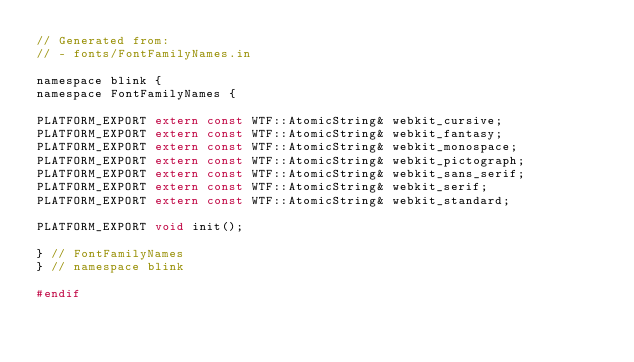Convert code to text. <code><loc_0><loc_0><loc_500><loc_500><_C_>// Generated from:
// - fonts/FontFamilyNames.in

namespace blink {
namespace FontFamilyNames {

PLATFORM_EXPORT extern const WTF::AtomicString& webkit_cursive;
PLATFORM_EXPORT extern const WTF::AtomicString& webkit_fantasy;
PLATFORM_EXPORT extern const WTF::AtomicString& webkit_monospace;
PLATFORM_EXPORT extern const WTF::AtomicString& webkit_pictograph;
PLATFORM_EXPORT extern const WTF::AtomicString& webkit_sans_serif;
PLATFORM_EXPORT extern const WTF::AtomicString& webkit_serif;
PLATFORM_EXPORT extern const WTF::AtomicString& webkit_standard;

PLATFORM_EXPORT void init();

} // FontFamilyNames
} // namespace blink

#endif
</code> 